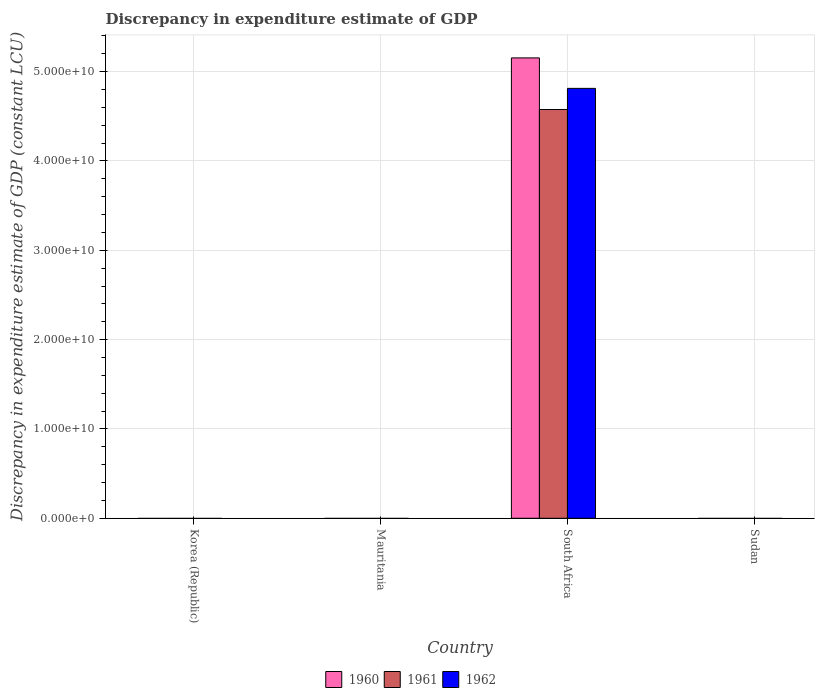Are the number of bars per tick equal to the number of legend labels?
Ensure brevity in your answer.  No. Are the number of bars on each tick of the X-axis equal?
Provide a short and direct response. No. How many bars are there on the 4th tick from the left?
Your response must be concise. 0. What is the discrepancy in expenditure estimate of GDP in 1961 in Sudan?
Provide a succinct answer. 0. Across all countries, what is the maximum discrepancy in expenditure estimate of GDP in 1960?
Keep it short and to the point. 5.15e+1. Across all countries, what is the minimum discrepancy in expenditure estimate of GDP in 1961?
Your answer should be compact. 0. In which country was the discrepancy in expenditure estimate of GDP in 1960 maximum?
Your answer should be very brief. South Africa. What is the total discrepancy in expenditure estimate of GDP in 1961 in the graph?
Provide a short and direct response. 4.58e+1. What is the average discrepancy in expenditure estimate of GDP in 1962 per country?
Offer a very short reply. 1.20e+1. What is the difference between the discrepancy in expenditure estimate of GDP of/in 1961 and discrepancy in expenditure estimate of GDP of/in 1962 in South Africa?
Make the answer very short. -2.37e+09. In how many countries, is the discrepancy in expenditure estimate of GDP in 1960 greater than 36000000000 LCU?
Your response must be concise. 1. What is the difference between the highest and the lowest discrepancy in expenditure estimate of GDP in 1962?
Your answer should be very brief. 4.81e+1. How many bars are there?
Your answer should be very brief. 3. Are all the bars in the graph horizontal?
Ensure brevity in your answer.  No. How many countries are there in the graph?
Offer a very short reply. 4. What is the difference between two consecutive major ticks on the Y-axis?
Ensure brevity in your answer.  1.00e+1. Where does the legend appear in the graph?
Make the answer very short. Bottom center. What is the title of the graph?
Make the answer very short. Discrepancy in expenditure estimate of GDP. What is the label or title of the Y-axis?
Provide a succinct answer. Discrepancy in expenditure estimate of GDP (constant LCU). What is the Discrepancy in expenditure estimate of GDP (constant LCU) of 1961 in Korea (Republic)?
Ensure brevity in your answer.  0. What is the Discrepancy in expenditure estimate of GDP (constant LCU) in 1962 in Mauritania?
Give a very brief answer. 0. What is the Discrepancy in expenditure estimate of GDP (constant LCU) in 1960 in South Africa?
Provide a short and direct response. 5.15e+1. What is the Discrepancy in expenditure estimate of GDP (constant LCU) of 1961 in South Africa?
Ensure brevity in your answer.  4.58e+1. What is the Discrepancy in expenditure estimate of GDP (constant LCU) of 1962 in South Africa?
Your response must be concise. 4.81e+1. What is the Discrepancy in expenditure estimate of GDP (constant LCU) in 1960 in Sudan?
Your response must be concise. 0. What is the Discrepancy in expenditure estimate of GDP (constant LCU) of 1962 in Sudan?
Ensure brevity in your answer.  0. Across all countries, what is the maximum Discrepancy in expenditure estimate of GDP (constant LCU) of 1960?
Your answer should be compact. 5.15e+1. Across all countries, what is the maximum Discrepancy in expenditure estimate of GDP (constant LCU) of 1961?
Your response must be concise. 4.58e+1. Across all countries, what is the maximum Discrepancy in expenditure estimate of GDP (constant LCU) in 1962?
Offer a terse response. 4.81e+1. Across all countries, what is the minimum Discrepancy in expenditure estimate of GDP (constant LCU) of 1960?
Give a very brief answer. 0. Across all countries, what is the minimum Discrepancy in expenditure estimate of GDP (constant LCU) of 1961?
Provide a short and direct response. 0. Across all countries, what is the minimum Discrepancy in expenditure estimate of GDP (constant LCU) of 1962?
Your answer should be very brief. 0. What is the total Discrepancy in expenditure estimate of GDP (constant LCU) in 1960 in the graph?
Provide a short and direct response. 5.15e+1. What is the total Discrepancy in expenditure estimate of GDP (constant LCU) in 1961 in the graph?
Provide a succinct answer. 4.58e+1. What is the total Discrepancy in expenditure estimate of GDP (constant LCU) in 1962 in the graph?
Keep it short and to the point. 4.81e+1. What is the average Discrepancy in expenditure estimate of GDP (constant LCU) in 1960 per country?
Ensure brevity in your answer.  1.29e+1. What is the average Discrepancy in expenditure estimate of GDP (constant LCU) in 1961 per country?
Provide a short and direct response. 1.14e+1. What is the average Discrepancy in expenditure estimate of GDP (constant LCU) in 1962 per country?
Your response must be concise. 1.20e+1. What is the difference between the Discrepancy in expenditure estimate of GDP (constant LCU) in 1960 and Discrepancy in expenditure estimate of GDP (constant LCU) in 1961 in South Africa?
Provide a succinct answer. 5.78e+09. What is the difference between the Discrepancy in expenditure estimate of GDP (constant LCU) of 1960 and Discrepancy in expenditure estimate of GDP (constant LCU) of 1962 in South Africa?
Ensure brevity in your answer.  3.41e+09. What is the difference between the Discrepancy in expenditure estimate of GDP (constant LCU) in 1961 and Discrepancy in expenditure estimate of GDP (constant LCU) in 1962 in South Africa?
Offer a terse response. -2.37e+09. What is the difference between the highest and the lowest Discrepancy in expenditure estimate of GDP (constant LCU) of 1960?
Your answer should be very brief. 5.15e+1. What is the difference between the highest and the lowest Discrepancy in expenditure estimate of GDP (constant LCU) in 1961?
Your answer should be very brief. 4.58e+1. What is the difference between the highest and the lowest Discrepancy in expenditure estimate of GDP (constant LCU) in 1962?
Provide a succinct answer. 4.81e+1. 